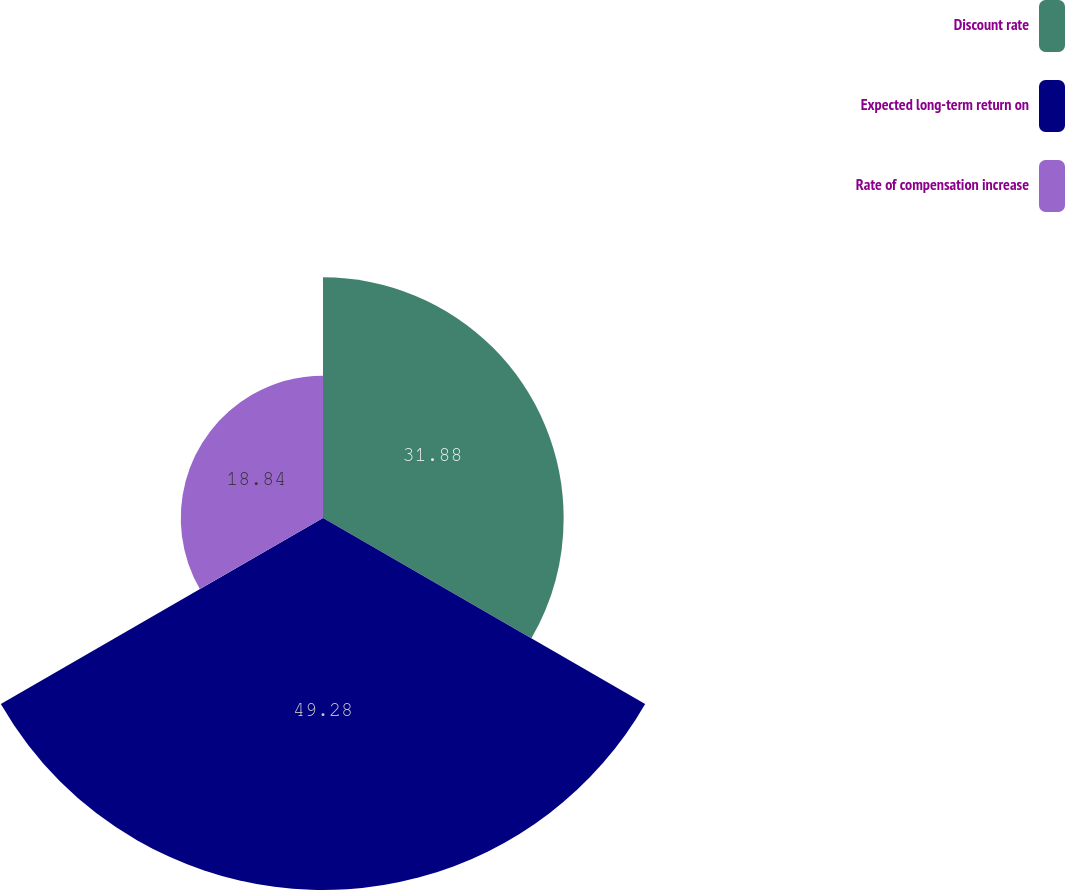Convert chart. <chart><loc_0><loc_0><loc_500><loc_500><pie_chart><fcel>Discount rate<fcel>Expected long-term return on<fcel>Rate of compensation increase<nl><fcel>31.88%<fcel>49.28%<fcel>18.84%<nl></chart> 